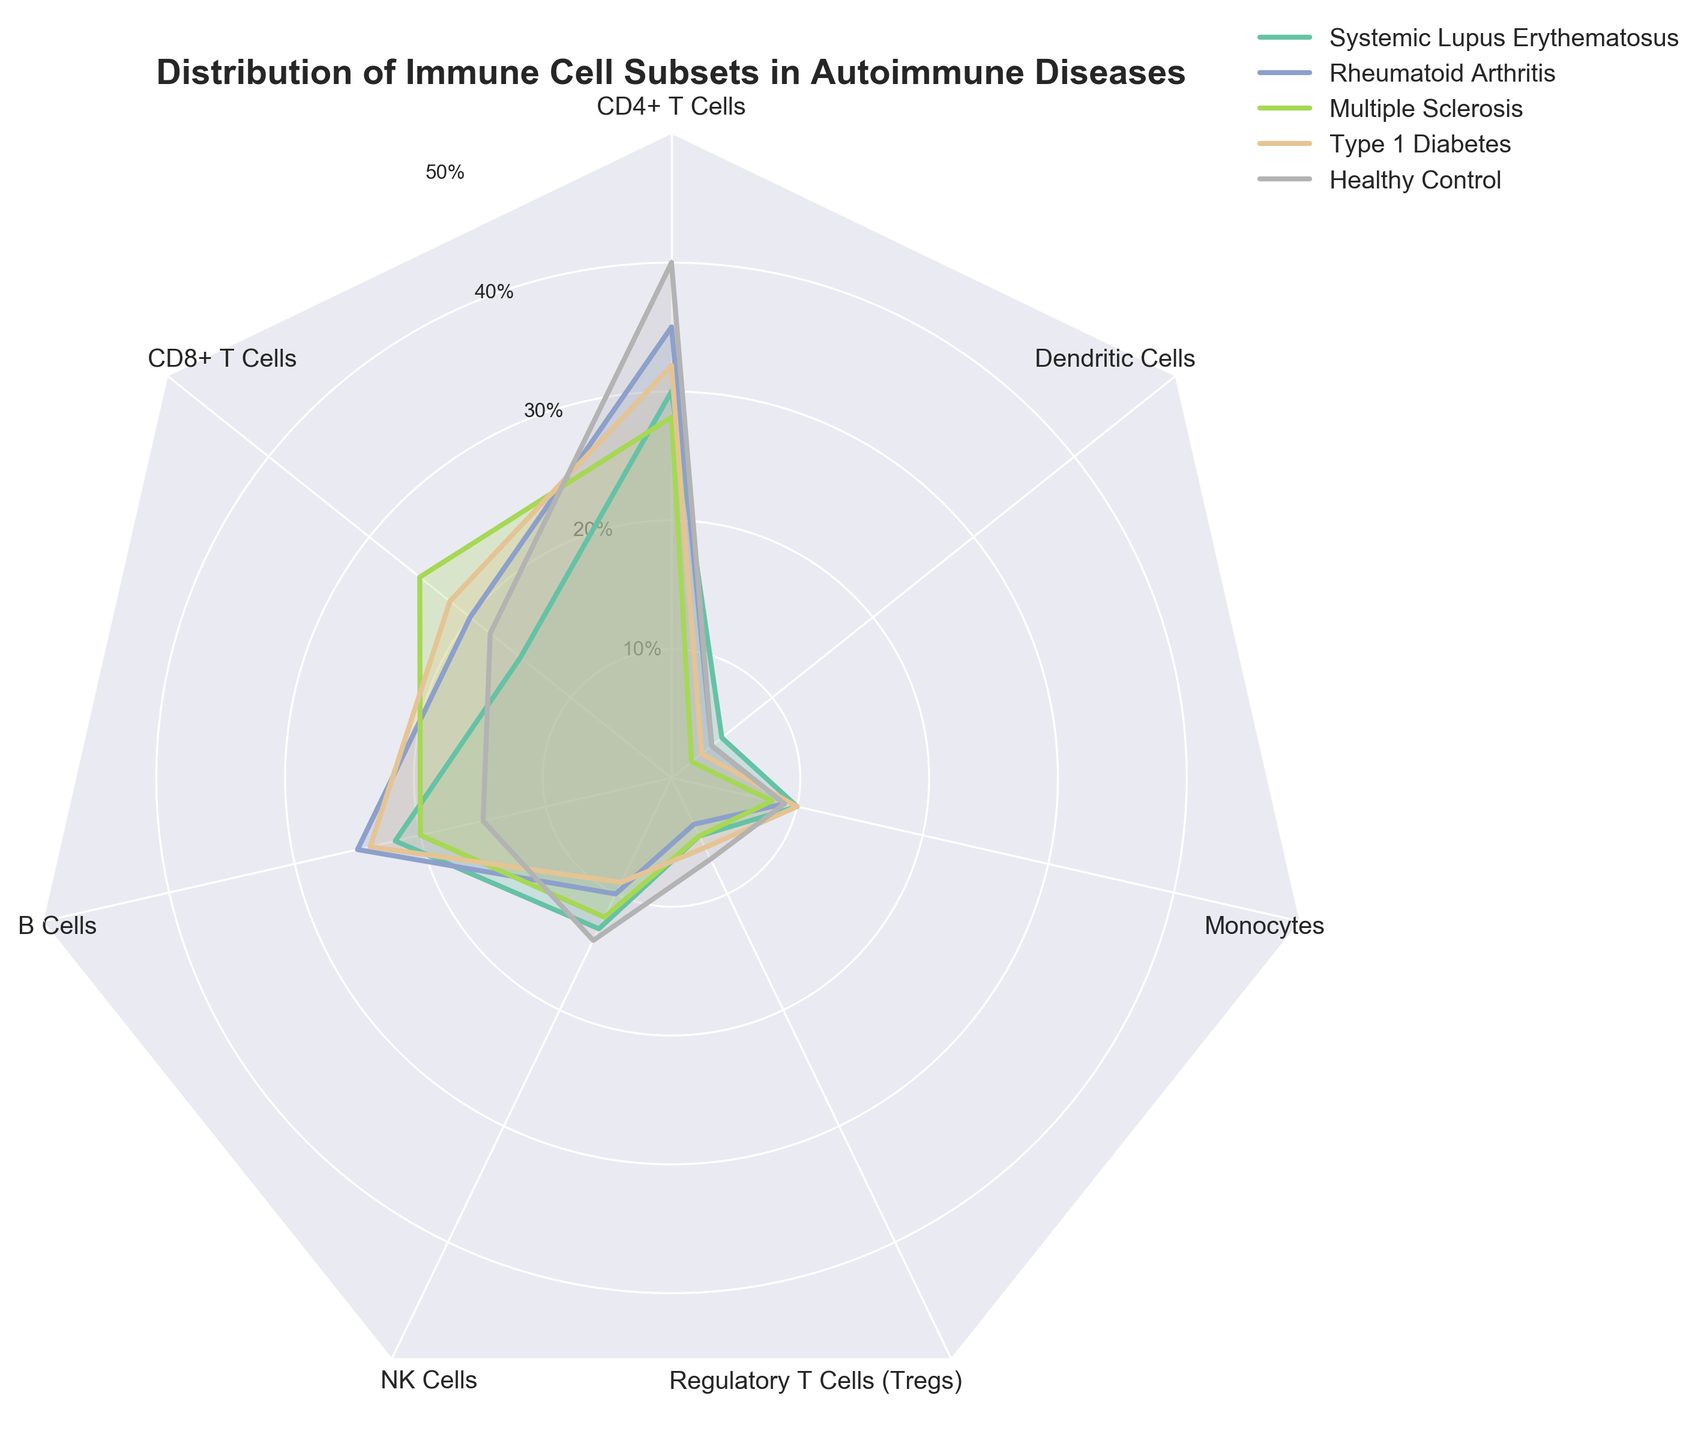What is the color used to represent Systemic Lupus Erythematosus? The radar chart uses different colors for each autoimmune disease. The color for Systemic Lupus Erythematosus can be identified by looking at the legend, where each disease is paired with a specific color.
Answer: Look at the legend and see the color next to "Systemic Lupus Erythematosus." How many immune cell subsets are depicted in the radar chart? The radar chart displays different immune cell subsets around its perimeter. These subsets are typically labeled at each segment of the radar plot. By counting these labels, we can determine the number of subsets represented in the chart.
Answer: 7 What immune cell has the highest percentage in Multiple Sclerosis? To find the immune cell subset with the highest percentage in Multiple Sclerosis, locate the plot line for Multiple Sclerosis and observe which segment reaches the highest value.
Answer: CD4+ T Cells Which autoimmune disease shows the lowest percentage of CD8+ T Cells? To determine this, look at the percentage values for CD8+ T Cells across all diseases in the radar chart. Identify which disease’s plot line is closest to the center for the CD8+ T Cells segment.
Answer: Systemic Lupus Erythematosus Compare the percentage of B Cells in Rheumatoid Arthritis and Healthy Control; which is higher and by how much? Locate the segments for B Cells for both Rheumatoid Arthritis and Healthy Control. Compare their percentage values and determine how much higher one is than the other. Rheumatoid Arthritis shows 25% while Healthy Control shows 15%, so the difference is 25% - 15% = 10%.
Answer: Rheumatoid Arthritis, 10% What is the average percentage of Monocytes across all represented groups? First, sum the percentage values of Monocytes for each group: Systemic Lupus Erythematosus (10%), Rheumatoid Arthritis (9%), Multiple Sclerosis (8%), Type 1 Diabetes (10%), and Healthy Control (9%). Then, divide the total by the number of groups. (10 + 9 + 8 + 10 + 9) / 5 = 46 / 5 = 9.2%.
Answer: 9.2% Which disease has the most similar distribution pattern to Healthy Control? To determine this, visually compare the shapes of the polygons representing each disease with the one for Healthy Control. Look for the most similar pattern in terms of angles and lengths.
Answer: Type 1 Diabetes Explain the visual indication of the minimum value on the radar plot. On a radar chart, the minimum value is visually indicated by the innermost point near the center of the plot. For any segment corresponding to a specific cell subset, the closest point to the center represents the minimum value among all groups. The exact positioning can be determined by the axis labels for each subset and the radial grid lines representing values. This minimum value will typically be located at the lowest radial distance from the center when compared with other corresponding points.
Answer: Near the center of the radar plot Which immune cell subset shows the greatest variation in percentage across all diseases? Look at the different cell subsets and observe the spread of their values across all diseases. The one with the widest range from its minimum to maximum percentage indicates the greatest variation. Calculate the difference for each subset: For example, CD4+ T Cells range from 28% to 40%, giving a variation of 12%. Calculate similarly for others and compare.
Answer: B Cells (15% to 25%, variation = 10%) 